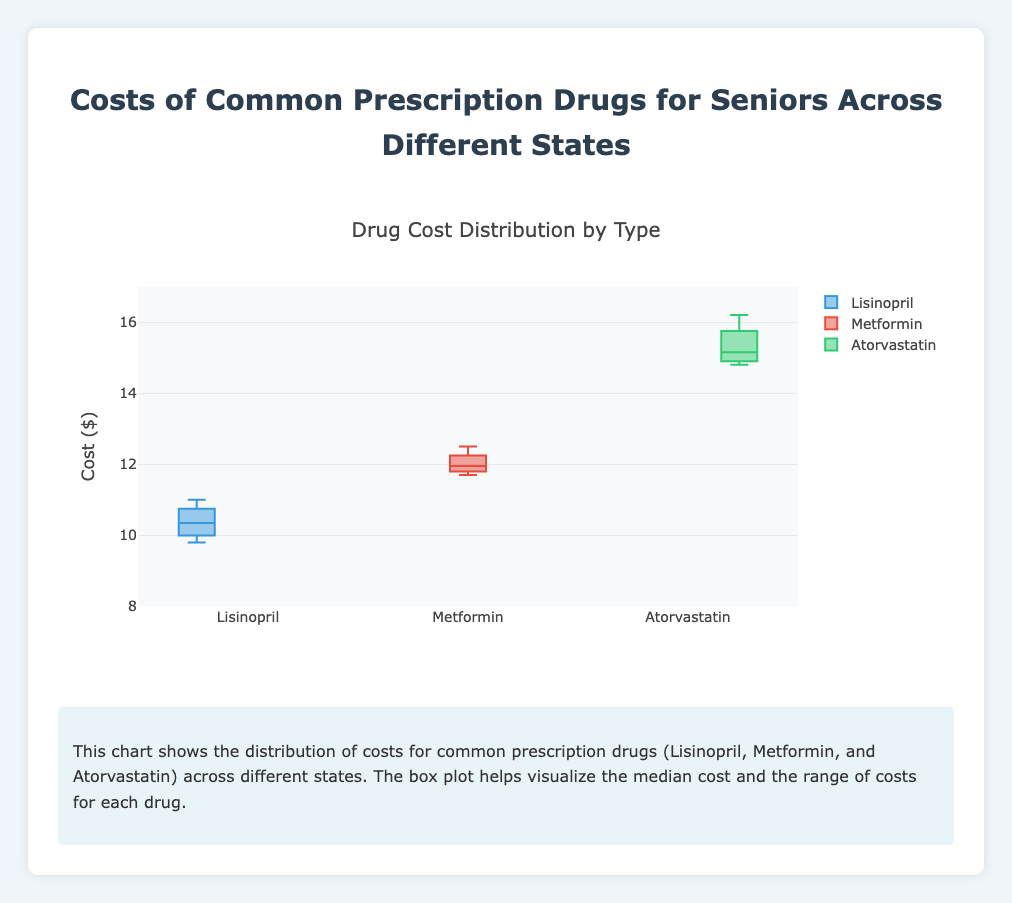What is the title of the chart? The title of the chart is usually prominently displayed at the top and provides a summary of what the chart is about. Here, the title is "Drug Cost Distribution by Type."
Answer: Drug Cost Distribution by Type What states are included in the data for the box plot? By looking at the box plot and the data provided, you can identify the specific states for which the drug cost data was collected: California, Florida, New York, and Texas.
Answer: California, Florida, New York, Texas What is the range of costs for Atorvastatin? The range is determined by the minimum and maximum values shown for Atorvastatin in the box plot. Here, the minimum cost is 14.8, and the maximum is 16.2.
Answer: 14.8 to 16.2 Which drug has the highest median cost? The median cost is represented by the line within each box in the box plot. Comparing these lines across all the drugs, Atorvastatin has the highest median cost.
Answer: Atorvastatin How does the cost of Lisinopril compare across different states? To compare Lisinopril costs, observe the y-values in California, Florida, New York, and Texas. The values range between 9.8 and 11.0, showing moderate variation across states.
Answer: 9.8 to 11.0 What is the interquartile range (IQR) for Metformin? The IQR is calculated by subtracting the value at the Q1 quartile from the value at the Q3 quartile. For Metformin, these can be inferred from the quartile lines on the box plot. Assume Q1 is ~11.7 and Q3 is ~12.5. Thus, 12.5 - 11.7.
Answer: 0.8 Which drug has the smallest cost variability? Variability can be inferred from the height of the box in the box plot, representing the IQR. The drug with the smallest box or height of the whiskers has the least variability. Here, Lisinopril seems to have smaller variability compared to Metformin and Atorvastatin.
Answer: Lisinopril How does the median cost of Metformin in California compare to the median cost of Metformin overall? Look at the median line for Metformin in California and compare it to where the median line is in the overall Metformin box plot. The median in California is similar to the overall median.
Answer: Similar What insight does the chart provide about drug costs for seniors in different states? The chart shows the distribution and variability of drug costs for Lisinopril, Metformin, and Atorvastatin across California, Florida, New York, and Texas. It can be seen that there are differences in median costs and ranges, with Atorvastatin generally more expensive and having higher variability.
Answer: Drug costs vary by drug type and state Which state has the highest maximum cost for prescription drugs? By observing the box plot's whiskers, the highest maximum point can be found. New York has the highest maximum cost for Atorvastatin at 16.2.
Answer: New York 